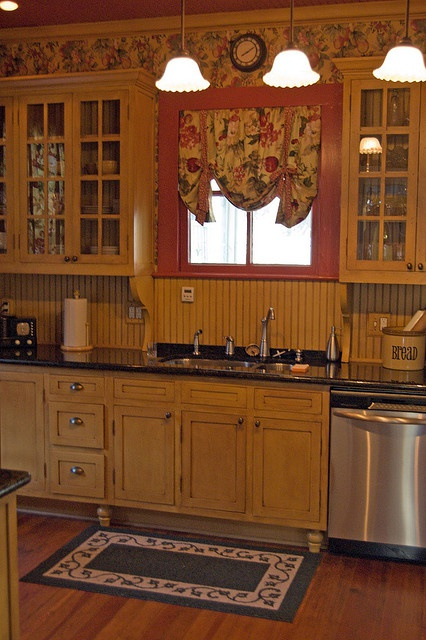Describe the objects in this image and their specific colors. I can see oven in maroon, brown, gray, black, and darkgray tones, bowl in maroon, olive, and black tones, microwave in maroon, black, and brown tones, clock in maroon, brown, and black tones, and sink in maroon, black, and gray tones in this image. 